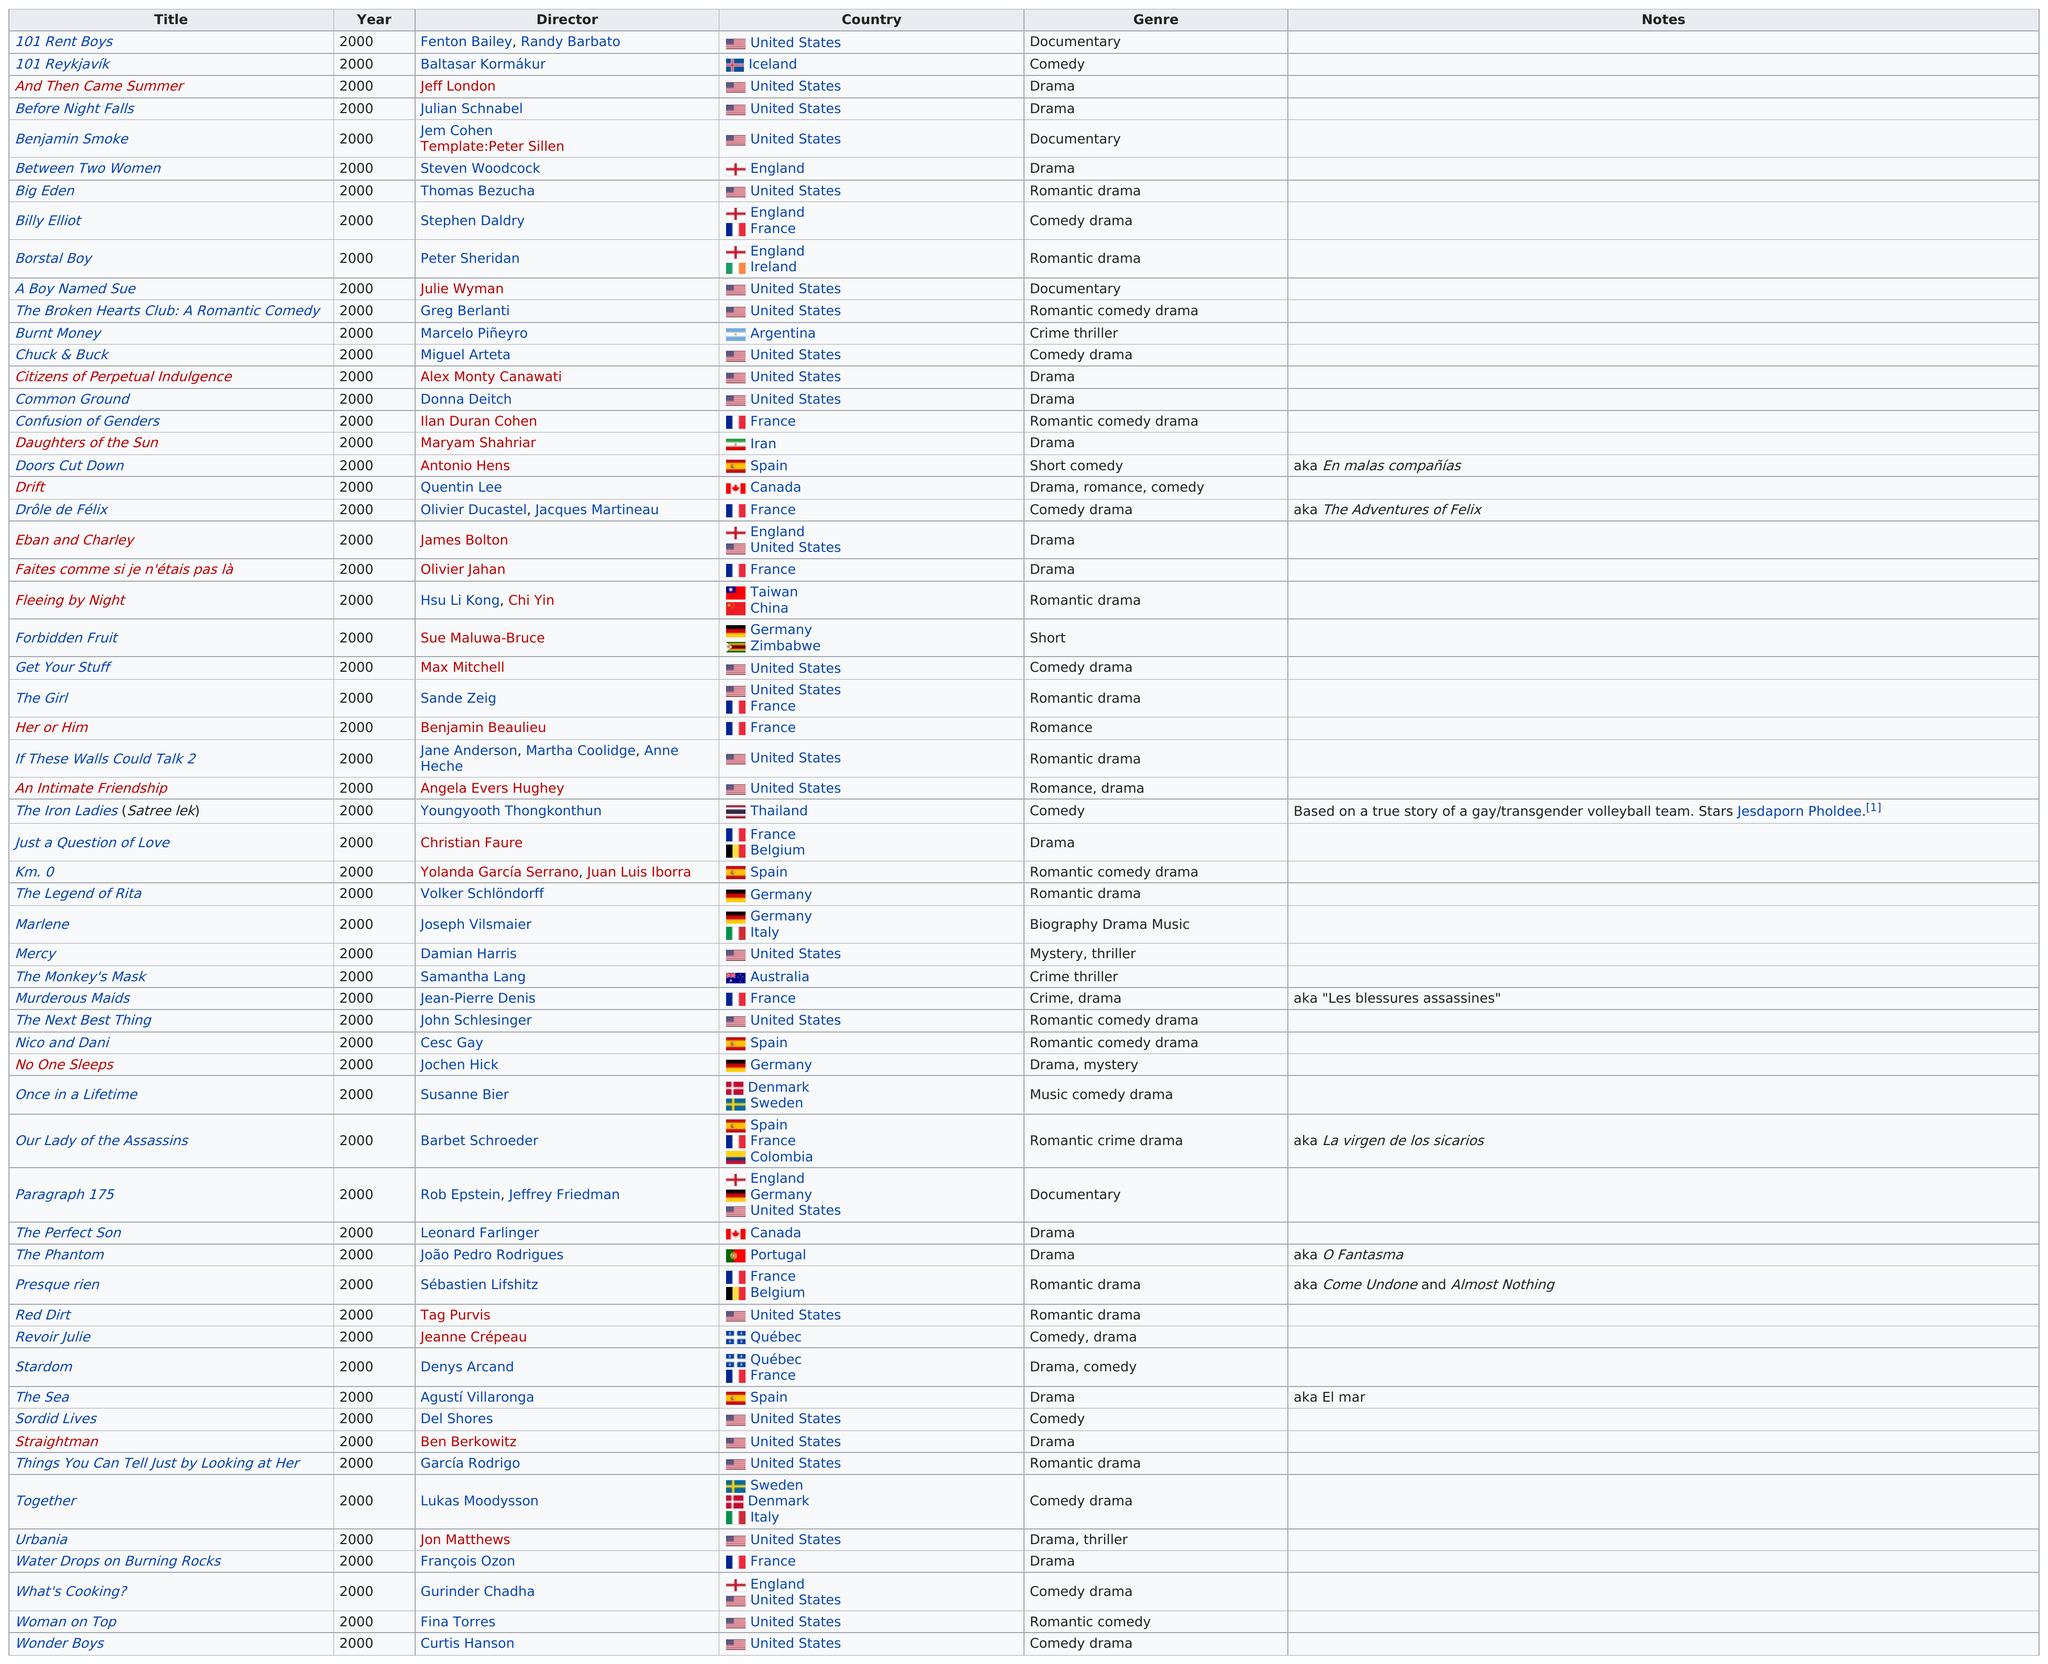Identify some key points in this picture. Jeff London directed both 'Before Night Falls' and 'And Then Came Summer'. In this year, there were two crime thrillers that were released in this particular category. The genre that was used the most was drama. There are 12 films in this category that originated from France during this year. The movie directed by Angela Evers Hughey this year, which was made in the same country as 'The Next Best Thing', is titled 'An Intimate Friendship'. 